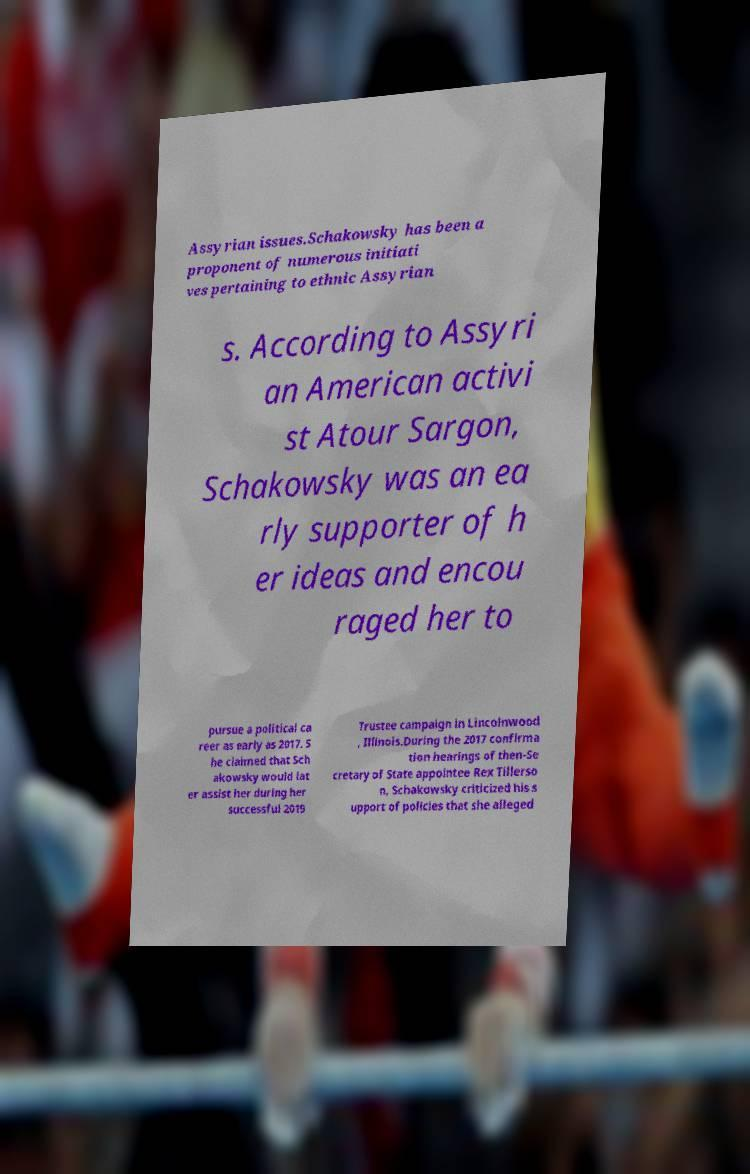Please read and relay the text visible in this image. What does it say? Assyrian issues.Schakowsky has been a proponent of numerous initiati ves pertaining to ethnic Assyrian s. According to Assyri an American activi st Atour Sargon, Schakowsky was an ea rly supporter of h er ideas and encou raged her to pursue a political ca reer as early as 2017. S he claimed that Sch akowsky would lat er assist her during her successful 2019 Trustee campaign in Lincolnwood , Illinois.During the 2017 confirma tion hearings of then-Se cretary of State appointee Rex Tillerso n, Schakowsky criticized his s upport of policies that she alleged 